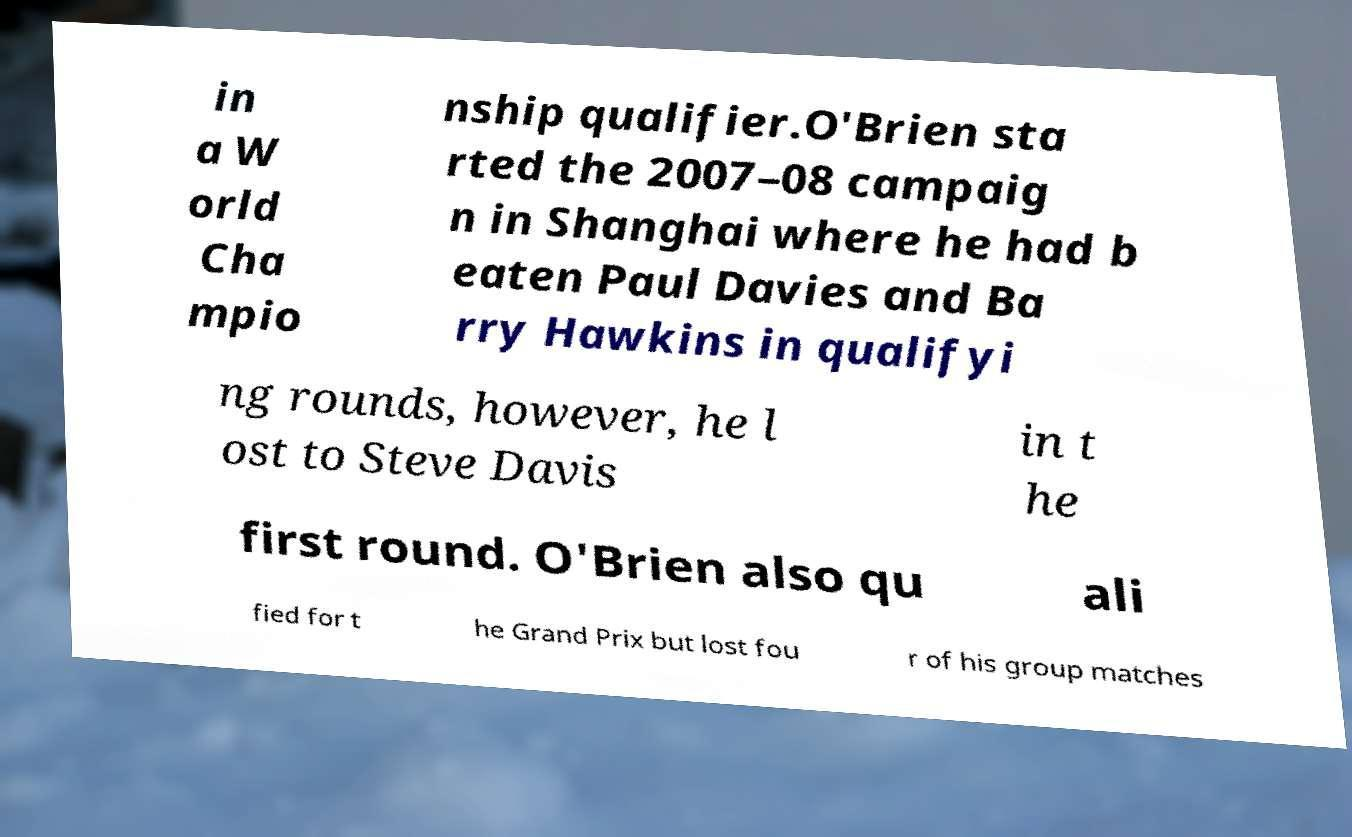Can you read and provide the text displayed in the image?This photo seems to have some interesting text. Can you extract and type it out for me? in a W orld Cha mpio nship qualifier.O'Brien sta rted the 2007–08 campaig n in Shanghai where he had b eaten Paul Davies and Ba rry Hawkins in qualifyi ng rounds, however, he l ost to Steve Davis in t he first round. O'Brien also qu ali fied for t he Grand Prix but lost fou r of his group matches 